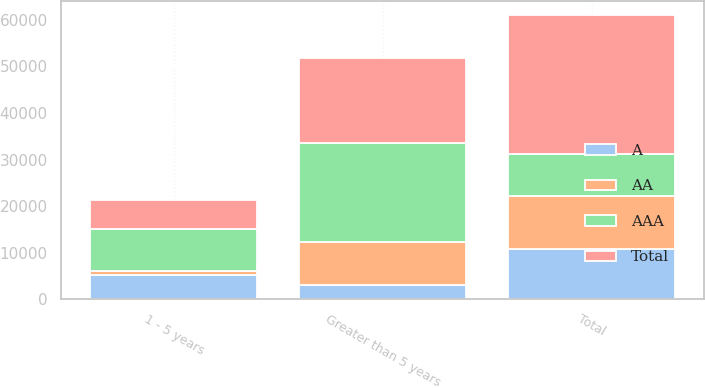<chart> <loc_0><loc_0><loc_500><loc_500><stacked_bar_chart><ecel><fcel>1 - 5 years<fcel>Greater than 5 years<fcel>Total<nl><fcel>AA<fcel>881<fcel>9202<fcel>11345<nl><fcel>A<fcel>5192<fcel>3028<fcel>10726<nl><fcel>AAA<fcel>9072<fcel>21415<fcel>9202<nl><fcel>Total<fcel>6155<fcel>18092<fcel>29703<nl></chart> 